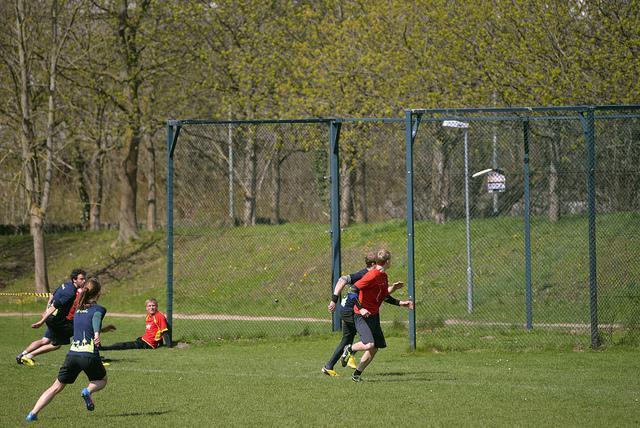How many people can you see?
Give a very brief answer. 3. How many ripe bananas are in the picture?
Give a very brief answer. 0. 